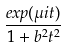Convert formula to latex. <formula><loc_0><loc_0><loc_500><loc_500>\frac { e x p ( \mu i t ) } { 1 + b ^ { 2 } t ^ { 2 } }</formula> 